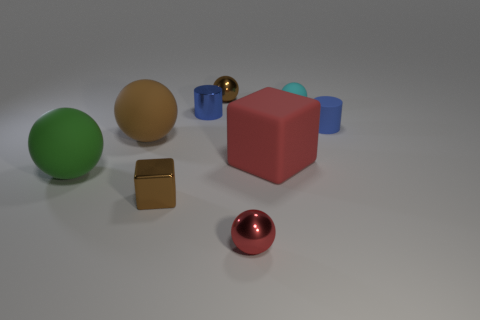Which objects in the picture could feasibly float on water? Based on the image, the blue and the green objects, which appear to be spheres, might be able to float depending on their material. If they're made of a lightweight and waterproof material like plastic, they would likely float. 